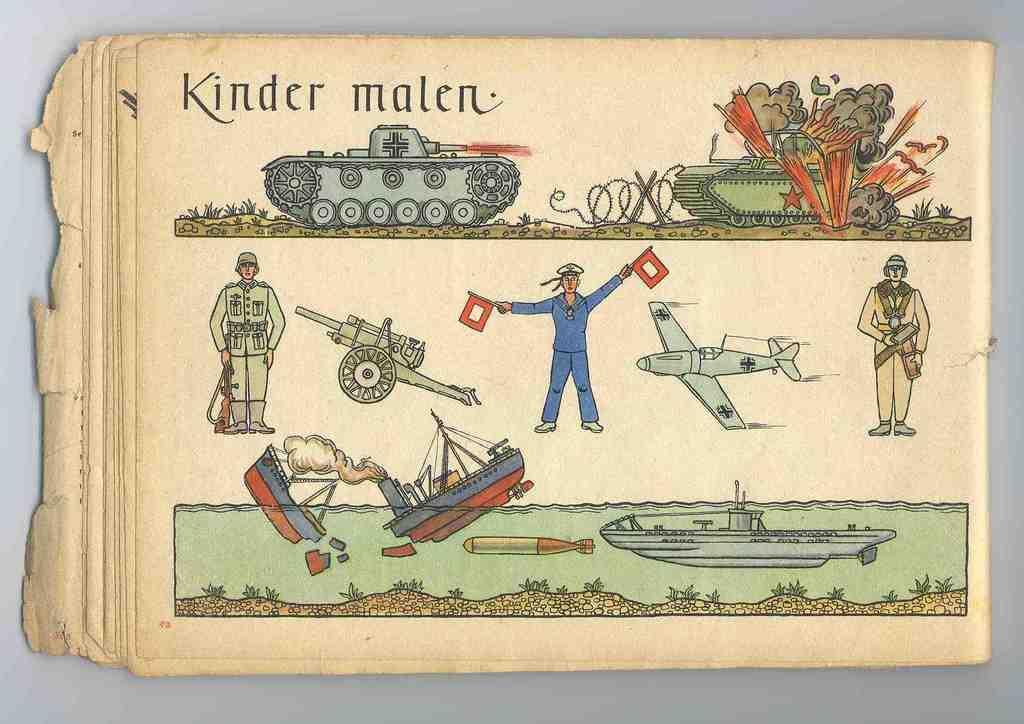In one or two sentences, can you explain what this image depicts? In this image in the center there are some papers and in the papers there is some text and some persons and boats and some other objects, and in the background there is wall. 